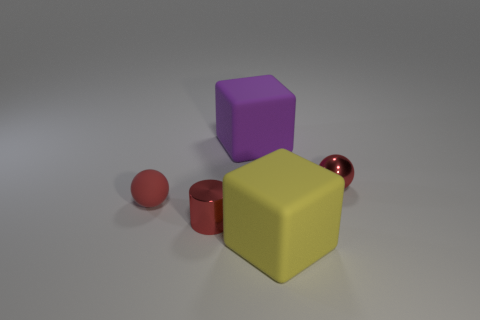There is a purple object that is the same material as the yellow thing; what size is it?
Offer a terse response. Large. What number of gray objects are either blocks or small rubber spheres?
Offer a very short reply. 0. What is the shape of the shiny thing that is the same color as the small cylinder?
Offer a very short reply. Sphere. Is there anything else that has the same material as the red cylinder?
Offer a very short reply. Yes. There is a large object that is behind the small matte sphere; is its shape the same as the small red shiny thing that is on the left side of the big purple cube?
Give a very brief answer. No. What number of small spheres are there?
Keep it short and to the point. 2. There is a thing that is made of the same material as the cylinder; what is its shape?
Make the answer very short. Sphere. Are there any other things of the same color as the small rubber sphere?
Provide a short and direct response. Yes. Do the matte sphere and the sphere that is to the right of the yellow block have the same color?
Offer a very short reply. Yes. Is the number of large purple things right of the large yellow thing less than the number of cyan rubber cylinders?
Offer a terse response. No. 